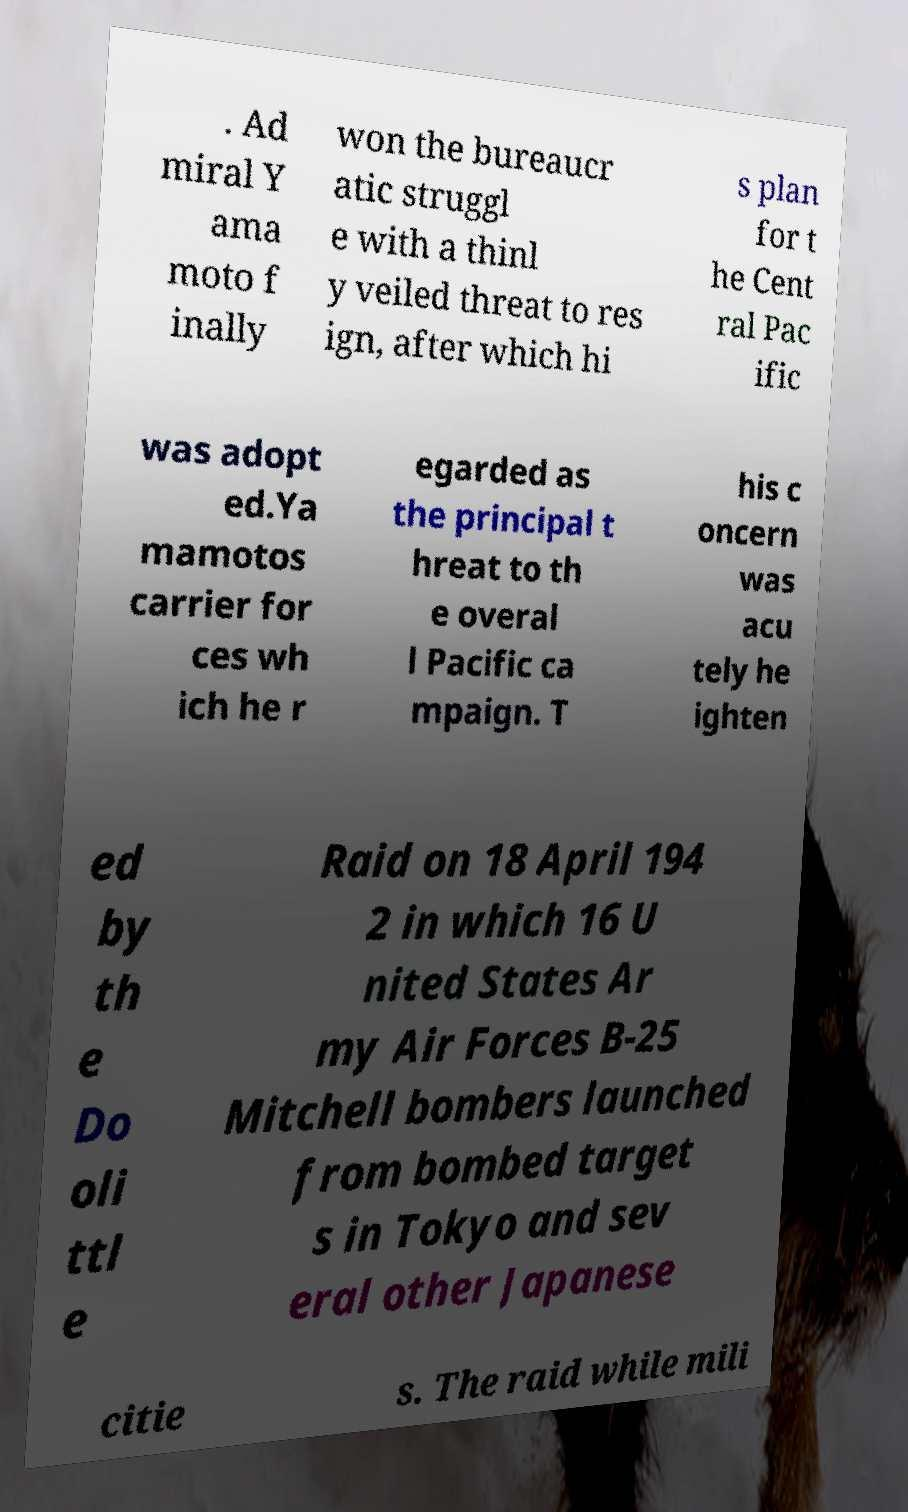Please read and relay the text visible in this image. What does it say? . Ad miral Y ama moto f inally won the bureaucr atic struggl e with a thinl y veiled threat to res ign, after which hi s plan for t he Cent ral Pac ific was adopt ed.Ya mamotos carrier for ces wh ich he r egarded as the principal t hreat to th e overal l Pacific ca mpaign. T his c oncern was acu tely he ighten ed by th e Do oli ttl e Raid on 18 April 194 2 in which 16 U nited States Ar my Air Forces B-25 Mitchell bombers launched from bombed target s in Tokyo and sev eral other Japanese citie s. The raid while mili 